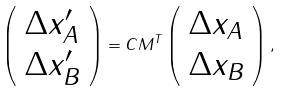<formula> <loc_0><loc_0><loc_500><loc_500>\left ( \begin{array} { l } \Delta x _ { A } ^ { \prime } \\ \Delta x _ { B } ^ { \prime } \end{array} \right ) = C { M } ^ { T } \left ( \begin{array} { l } \Delta x _ { A } \\ \Delta x _ { B } \end{array} \right ) ,</formula> 